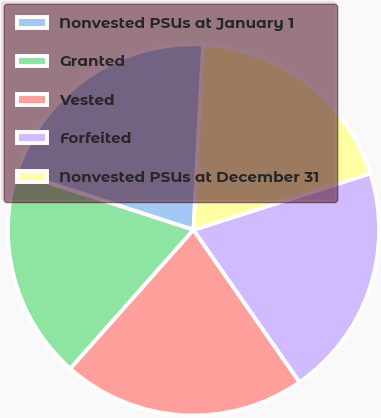<chart> <loc_0><loc_0><loc_500><loc_500><pie_chart><fcel>Nonvested PSUs at January 1<fcel>Granted<fcel>Vested<fcel>Forfeited<fcel>Nonvested PSUs at December 31<nl><fcel>20.84%<fcel>18.44%<fcel>21.24%<fcel>20.24%<fcel>19.24%<nl></chart> 